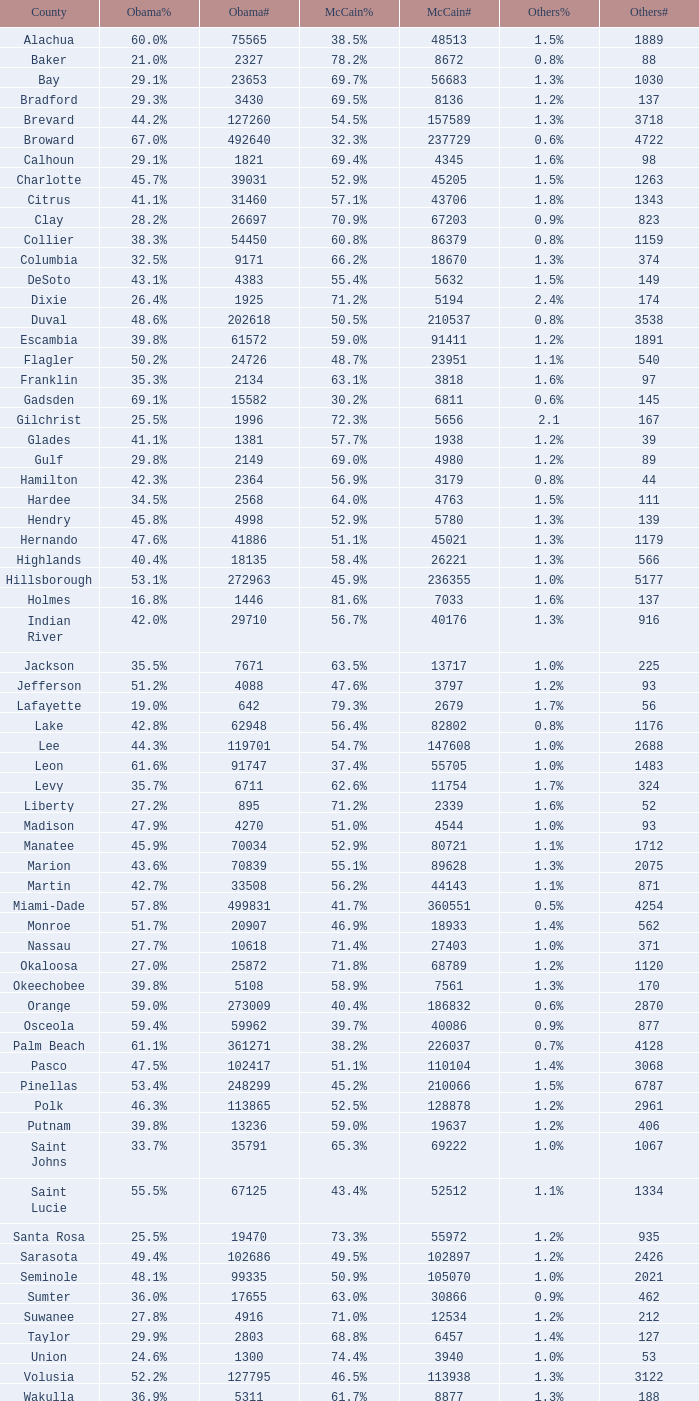9% and below 4520 1.3%. 